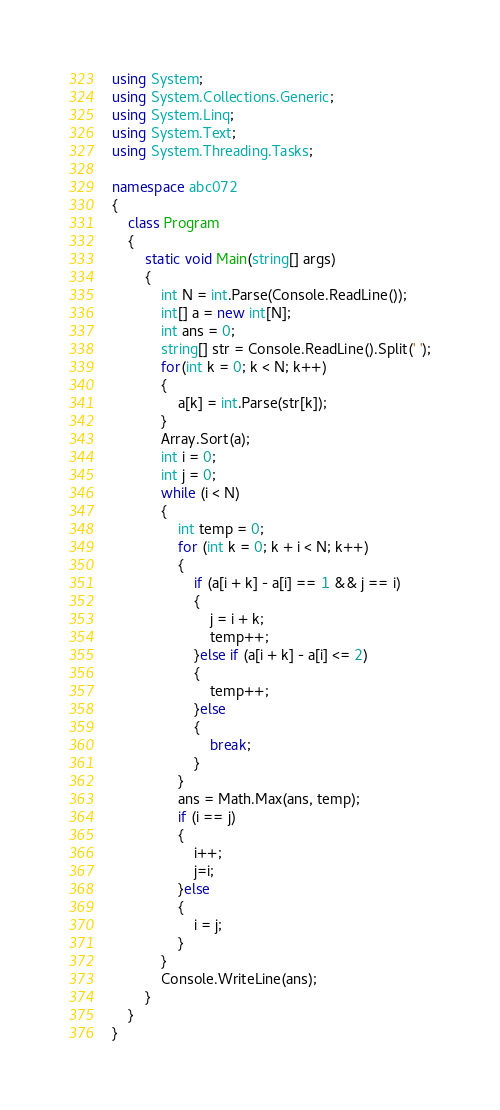Convert code to text. <code><loc_0><loc_0><loc_500><loc_500><_C#_>using System;
using System.Collections.Generic;
using System.Linq;
using System.Text;
using System.Threading.Tasks;

namespace abc072
{
    class Program
    {
        static void Main(string[] args)
        {
            int N = int.Parse(Console.ReadLine());
            int[] a = new int[N];
            int ans = 0;
            string[] str = Console.ReadLine().Split(' ');
            for(int k = 0; k < N; k++)
            {
                a[k] = int.Parse(str[k]);
            }
            Array.Sort(a);
            int i = 0;
            int j = 0;
            while (i < N)
            {
                int temp = 0;
                for (int k = 0; k + i < N; k++)
                {
                    if (a[i + k] - a[i] == 1 && j == i)
                    {
                        j = i + k;
                        temp++;
                    }else if (a[i + k] - a[i] <= 2)
                    {
                        temp++;
                    }else
                    {
                        break;
                    }
                }
                ans = Math.Max(ans, temp);
                if (i == j)
                {
                    i++;
                    j=i;
                }else
                {
                    i = j;
                }
            }
            Console.WriteLine(ans);
        }
    }
}
</code> 